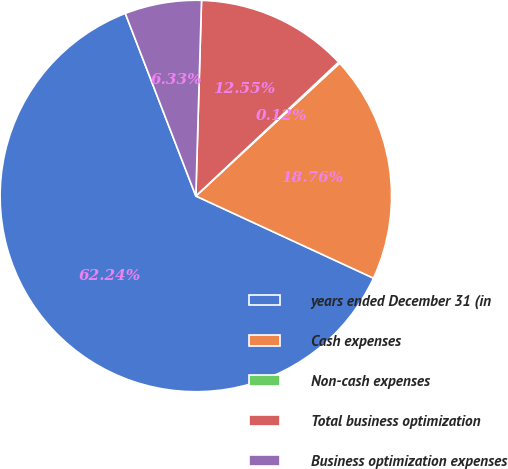Convert chart to OTSL. <chart><loc_0><loc_0><loc_500><loc_500><pie_chart><fcel>years ended December 31 (in<fcel>Cash expenses<fcel>Non-cash expenses<fcel>Total business optimization<fcel>Business optimization expenses<nl><fcel>62.24%<fcel>18.76%<fcel>0.12%<fcel>12.55%<fcel>6.33%<nl></chart> 